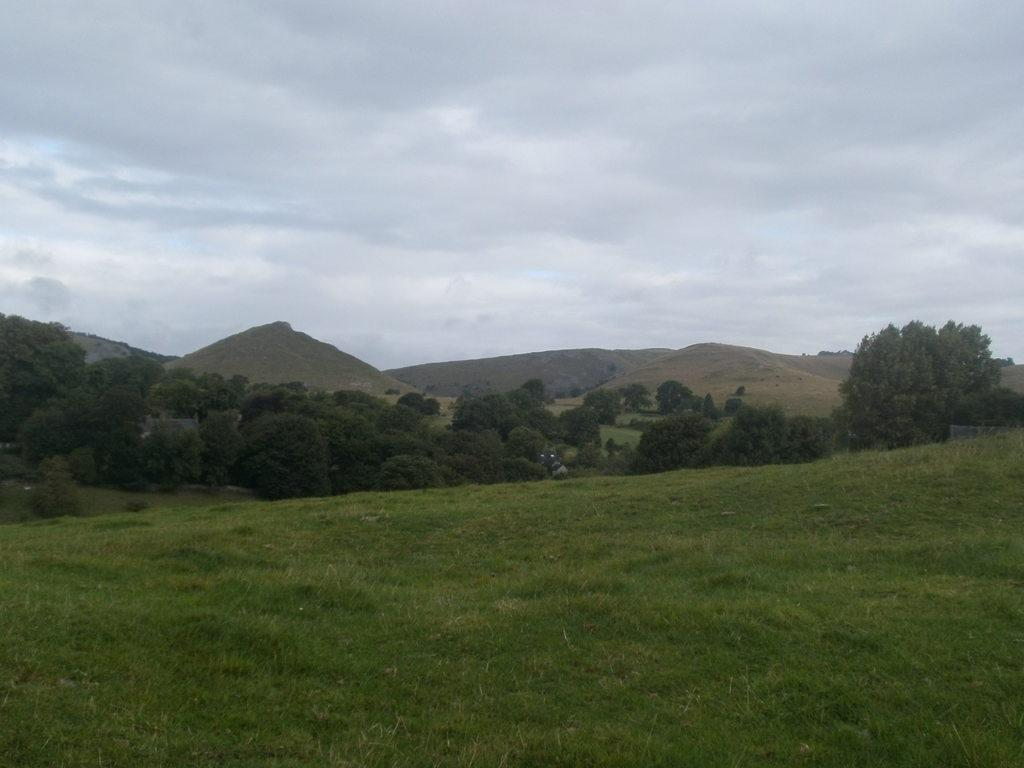What type of ground is visible in the image? There is a greenery ground in the image. What can be seen in the background of the image? There are trees and mountains in the background of the image. Where is the library located in the image? There is no library present in the image. What type of animal can be seen interacting with the trees in the image? There are no animals visible in the image; only trees and mountains are present. 